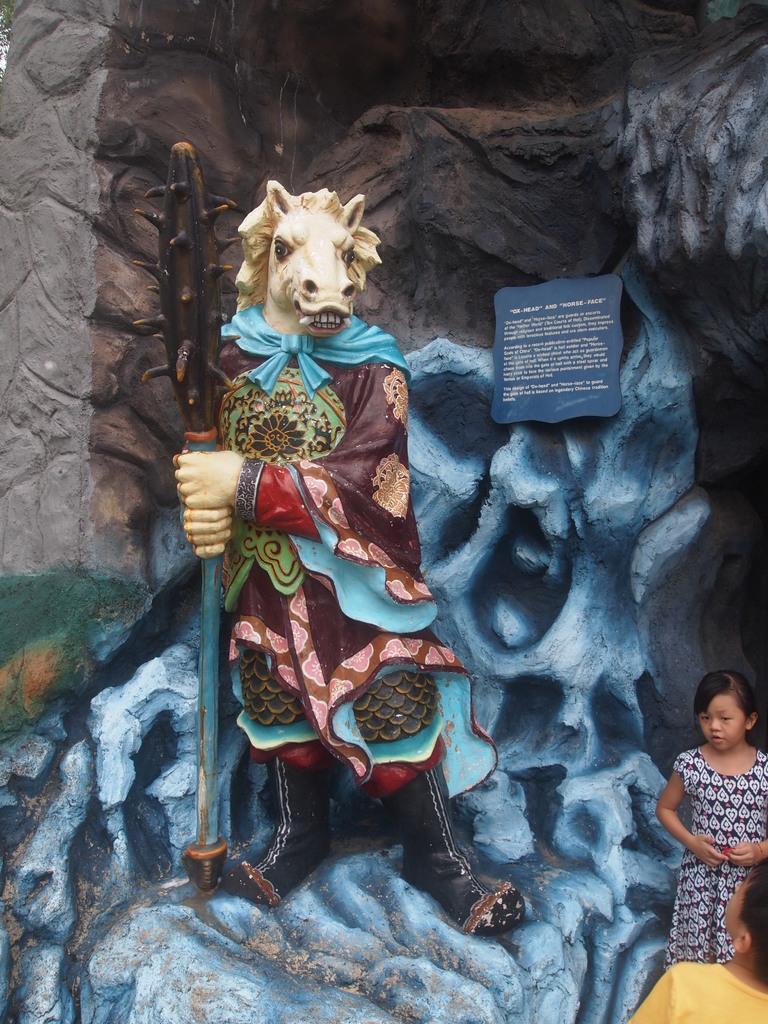Describe this image in one or two sentences. In the right bottom corner of the image there are two kids. And there is a statue of an animal. Behind the statue there is a wall with designs. And also there is a board with something written on it. 